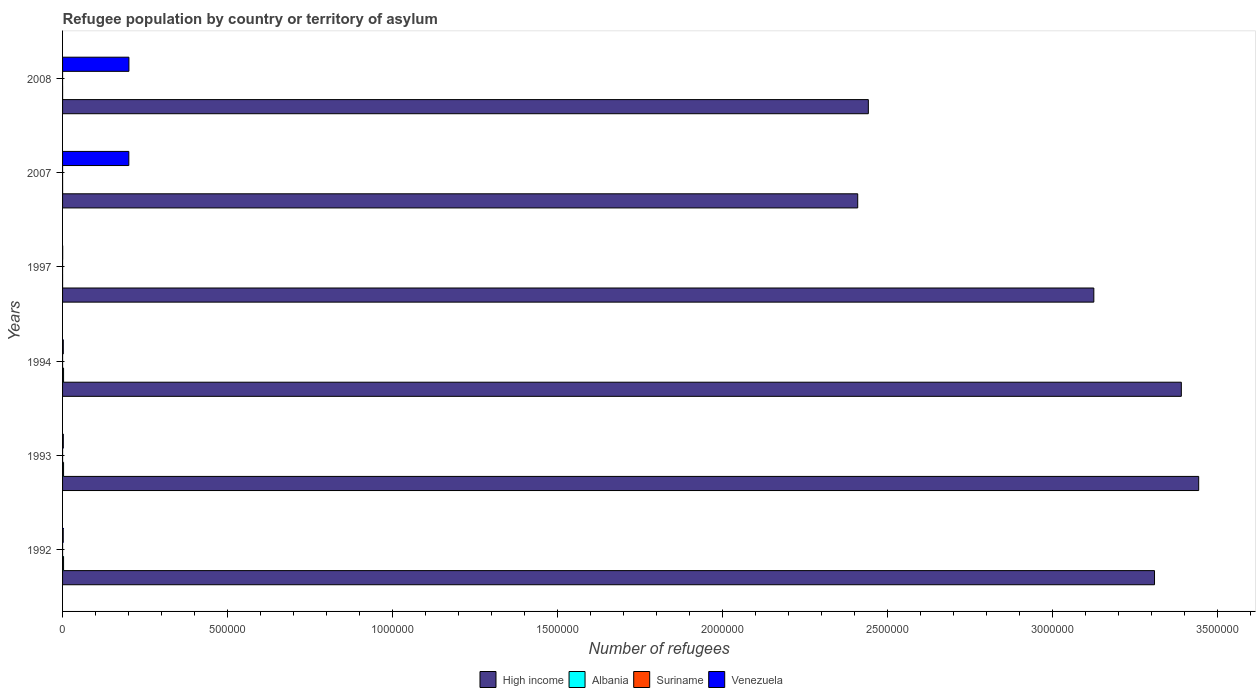How many different coloured bars are there?
Provide a succinct answer. 4. How many bars are there on the 2nd tick from the top?
Provide a succinct answer. 4. How many bars are there on the 6th tick from the bottom?
Offer a terse response. 4. What is the number of refugees in Albania in 2007?
Your answer should be very brief. 77. Across all years, what is the maximum number of refugees in High income?
Ensure brevity in your answer.  3.44e+06. Across all years, what is the minimum number of refugees in Venezuela?
Offer a terse response. 301. What is the total number of refugees in Suriname in the graph?
Offer a very short reply. 154. What is the difference between the number of refugees in Albania in 1994 and that in 1997?
Keep it short and to the point. 2970. What is the difference between the number of refugees in Albania in 1992 and the number of refugees in Suriname in 2007?
Keep it short and to the point. 2999. What is the average number of refugees in Suriname per year?
Make the answer very short. 25.67. In the year 1994, what is the difference between the number of refugees in Suriname and number of refugees in Venezuela?
Make the answer very short. -2138. What is the ratio of the number of refugees in Albania in 1994 to that in 2008?
Make the answer very short. 46.15. Is the number of refugees in High income in 1992 less than that in 2007?
Your answer should be compact. No. Is the difference between the number of refugees in Suriname in 1993 and 2008 greater than the difference between the number of refugees in Venezuela in 1993 and 2008?
Keep it short and to the point. Yes. What is the difference between the highest and the second highest number of refugees in Venezuela?
Give a very brief answer. 254. What is the difference between the highest and the lowest number of refugees in Venezuela?
Your response must be concise. 2.01e+05. In how many years, is the number of refugees in Albania greater than the average number of refugees in Albania taken over all years?
Keep it short and to the point. 3. What does the 1st bar from the top in 1993 represents?
Offer a terse response. Venezuela. Is it the case that in every year, the sum of the number of refugees in Suriname and number of refugees in Albania is greater than the number of refugees in Venezuela?
Give a very brief answer. No. How many bars are there?
Keep it short and to the point. 24. Are all the bars in the graph horizontal?
Ensure brevity in your answer.  Yes. What is the difference between two consecutive major ticks on the X-axis?
Provide a succinct answer. 5.00e+05. Does the graph contain grids?
Keep it short and to the point. No. How many legend labels are there?
Make the answer very short. 4. What is the title of the graph?
Your answer should be compact. Refugee population by country or territory of asylum. Does "Comoros" appear as one of the legend labels in the graph?
Provide a succinct answer. No. What is the label or title of the X-axis?
Keep it short and to the point. Number of refugees. What is the Number of refugees of High income in 1992?
Provide a short and direct response. 3.31e+06. What is the Number of refugees of Albania in 1992?
Offer a very short reply. 3000. What is the Number of refugees in Venezuela in 1992?
Keep it short and to the point. 1990. What is the Number of refugees of High income in 1993?
Your answer should be very brief. 3.44e+06. What is the Number of refugees of Albania in 1993?
Provide a short and direct response. 3000. What is the Number of refugees in Venezuela in 1993?
Your response must be concise. 2221. What is the Number of refugees of High income in 1994?
Ensure brevity in your answer.  3.39e+06. What is the Number of refugees of Albania in 1994?
Keep it short and to the point. 3000. What is the Number of refugees in Suriname in 1994?
Ensure brevity in your answer.  39. What is the Number of refugees in Venezuela in 1994?
Provide a short and direct response. 2177. What is the Number of refugees of High income in 1997?
Offer a terse response. 3.13e+06. What is the Number of refugees in Venezuela in 1997?
Ensure brevity in your answer.  301. What is the Number of refugees of High income in 2007?
Keep it short and to the point. 2.41e+06. What is the Number of refugees in Albania in 2007?
Give a very brief answer. 77. What is the Number of refugees in Suriname in 2007?
Provide a succinct answer. 1. What is the Number of refugees in Venezuela in 2007?
Make the answer very short. 2.01e+05. What is the Number of refugees of High income in 2008?
Your answer should be compact. 2.44e+06. What is the Number of refugees of Albania in 2008?
Offer a terse response. 65. What is the Number of refugees of Venezuela in 2008?
Keep it short and to the point. 2.01e+05. Across all years, what is the maximum Number of refugees in High income?
Make the answer very short. 3.44e+06. Across all years, what is the maximum Number of refugees of Albania?
Your answer should be compact. 3000. Across all years, what is the maximum Number of refugees of Venezuela?
Your answer should be compact. 2.01e+05. Across all years, what is the minimum Number of refugees of High income?
Give a very brief answer. 2.41e+06. Across all years, what is the minimum Number of refugees in Venezuela?
Your answer should be very brief. 301. What is the total Number of refugees in High income in the graph?
Provide a short and direct response. 1.81e+07. What is the total Number of refugees in Albania in the graph?
Provide a succinct answer. 9172. What is the total Number of refugees of Suriname in the graph?
Your response must be concise. 154. What is the total Number of refugees of Venezuela in the graph?
Offer a very short reply. 4.09e+05. What is the difference between the Number of refugees of High income in 1992 and that in 1993?
Your answer should be compact. -1.34e+05. What is the difference between the Number of refugees in Venezuela in 1992 and that in 1993?
Make the answer very short. -231. What is the difference between the Number of refugees in High income in 1992 and that in 1994?
Offer a very short reply. -8.13e+04. What is the difference between the Number of refugees of Suriname in 1992 and that in 1994?
Your answer should be compact. 13. What is the difference between the Number of refugees in Venezuela in 1992 and that in 1994?
Offer a very short reply. -187. What is the difference between the Number of refugees of High income in 1992 and that in 1997?
Make the answer very short. 1.84e+05. What is the difference between the Number of refugees in Albania in 1992 and that in 1997?
Your answer should be compact. 2970. What is the difference between the Number of refugees in Venezuela in 1992 and that in 1997?
Ensure brevity in your answer.  1689. What is the difference between the Number of refugees in High income in 1992 and that in 2007?
Your answer should be very brief. 9.00e+05. What is the difference between the Number of refugees of Albania in 1992 and that in 2007?
Offer a terse response. 2923. What is the difference between the Number of refugees of Suriname in 1992 and that in 2007?
Make the answer very short. 51. What is the difference between the Number of refugees in Venezuela in 1992 and that in 2007?
Your response must be concise. -1.99e+05. What is the difference between the Number of refugees of High income in 1992 and that in 2008?
Provide a short and direct response. 8.68e+05. What is the difference between the Number of refugees in Albania in 1992 and that in 2008?
Your answer should be very brief. 2935. What is the difference between the Number of refugees of Suriname in 1992 and that in 2008?
Provide a succinct answer. 51. What is the difference between the Number of refugees of Venezuela in 1992 and that in 2008?
Your answer should be very brief. -1.99e+05. What is the difference between the Number of refugees of High income in 1993 and that in 1994?
Offer a terse response. 5.26e+04. What is the difference between the Number of refugees in Albania in 1993 and that in 1994?
Offer a terse response. 0. What is the difference between the Number of refugees in Suriname in 1993 and that in 1994?
Offer a very short reply. 11. What is the difference between the Number of refugees in Venezuela in 1993 and that in 1994?
Your answer should be compact. 44. What is the difference between the Number of refugees of High income in 1993 and that in 1997?
Give a very brief answer. 3.18e+05. What is the difference between the Number of refugees of Albania in 1993 and that in 1997?
Make the answer very short. 2970. What is the difference between the Number of refugees in Venezuela in 1993 and that in 1997?
Ensure brevity in your answer.  1920. What is the difference between the Number of refugees in High income in 1993 and that in 2007?
Keep it short and to the point. 1.03e+06. What is the difference between the Number of refugees of Albania in 1993 and that in 2007?
Make the answer very short. 2923. What is the difference between the Number of refugees of Suriname in 1993 and that in 2007?
Offer a very short reply. 49. What is the difference between the Number of refugees of Venezuela in 1993 and that in 2007?
Make the answer very short. -1.99e+05. What is the difference between the Number of refugees of High income in 1993 and that in 2008?
Provide a succinct answer. 1.00e+06. What is the difference between the Number of refugees in Albania in 1993 and that in 2008?
Your answer should be compact. 2935. What is the difference between the Number of refugees of Suriname in 1993 and that in 2008?
Your answer should be compact. 49. What is the difference between the Number of refugees of Venezuela in 1993 and that in 2008?
Your answer should be very brief. -1.99e+05. What is the difference between the Number of refugees in High income in 1994 and that in 1997?
Provide a short and direct response. 2.65e+05. What is the difference between the Number of refugees of Albania in 1994 and that in 1997?
Your answer should be very brief. 2970. What is the difference between the Number of refugees of Suriname in 1994 and that in 1997?
Provide a succinct answer. 28. What is the difference between the Number of refugees of Venezuela in 1994 and that in 1997?
Keep it short and to the point. 1876. What is the difference between the Number of refugees of High income in 1994 and that in 2007?
Keep it short and to the point. 9.81e+05. What is the difference between the Number of refugees of Albania in 1994 and that in 2007?
Your response must be concise. 2923. What is the difference between the Number of refugees in Suriname in 1994 and that in 2007?
Your answer should be very brief. 38. What is the difference between the Number of refugees in Venezuela in 1994 and that in 2007?
Give a very brief answer. -1.99e+05. What is the difference between the Number of refugees in High income in 1994 and that in 2008?
Ensure brevity in your answer.  9.49e+05. What is the difference between the Number of refugees of Albania in 1994 and that in 2008?
Keep it short and to the point. 2935. What is the difference between the Number of refugees in Venezuela in 1994 and that in 2008?
Provide a succinct answer. -1.99e+05. What is the difference between the Number of refugees in High income in 1997 and that in 2007?
Give a very brief answer. 7.16e+05. What is the difference between the Number of refugees in Albania in 1997 and that in 2007?
Provide a short and direct response. -47. What is the difference between the Number of refugees of Suriname in 1997 and that in 2007?
Make the answer very short. 10. What is the difference between the Number of refugees in Venezuela in 1997 and that in 2007?
Offer a terse response. -2.01e+05. What is the difference between the Number of refugees in High income in 1997 and that in 2008?
Make the answer very short. 6.84e+05. What is the difference between the Number of refugees in Albania in 1997 and that in 2008?
Give a very brief answer. -35. What is the difference between the Number of refugees of Venezuela in 1997 and that in 2008?
Your answer should be very brief. -2.01e+05. What is the difference between the Number of refugees of High income in 2007 and that in 2008?
Ensure brevity in your answer.  -3.22e+04. What is the difference between the Number of refugees of Albania in 2007 and that in 2008?
Ensure brevity in your answer.  12. What is the difference between the Number of refugees of Venezuela in 2007 and that in 2008?
Provide a short and direct response. -254. What is the difference between the Number of refugees in High income in 1992 and the Number of refugees in Albania in 1993?
Keep it short and to the point. 3.31e+06. What is the difference between the Number of refugees in High income in 1992 and the Number of refugees in Suriname in 1993?
Provide a succinct answer. 3.31e+06. What is the difference between the Number of refugees in High income in 1992 and the Number of refugees in Venezuela in 1993?
Provide a succinct answer. 3.31e+06. What is the difference between the Number of refugees in Albania in 1992 and the Number of refugees in Suriname in 1993?
Offer a very short reply. 2950. What is the difference between the Number of refugees in Albania in 1992 and the Number of refugees in Venezuela in 1993?
Make the answer very short. 779. What is the difference between the Number of refugees of Suriname in 1992 and the Number of refugees of Venezuela in 1993?
Make the answer very short. -2169. What is the difference between the Number of refugees of High income in 1992 and the Number of refugees of Albania in 1994?
Make the answer very short. 3.31e+06. What is the difference between the Number of refugees in High income in 1992 and the Number of refugees in Suriname in 1994?
Offer a terse response. 3.31e+06. What is the difference between the Number of refugees of High income in 1992 and the Number of refugees of Venezuela in 1994?
Your response must be concise. 3.31e+06. What is the difference between the Number of refugees in Albania in 1992 and the Number of refugees in Suriname in 1994?
Make the answer very short. 2961. What is the difference between the Number of refugees in Albania in 1992 and the Number of refugees in Venezuela in 1994?
Make the answer very short. 823. What is the difference between the Number of refugees in Suriname in 1992 and the Number of refugees in Venezuela in 1994?
Your response must be concise. -2125. What is the difference between the Number of refugees of High income in 1992 and the Number of refugees of Albania in 1997?
Offer a terse response. 3.31e+06. What is the difference between the Number of refugees in High income in 1992 and the Number of refugees in Suriname in 1997?
Give a very brief answer. 3.31e+06. What is the difference between the Number of refugees of High income in 1992 and the Number of refugees of Venezuela in 1997?
Provide a short and direct response. 3.31e+06. What is the difference between the Number of refugees in Albania in 1992 and the Number of refugees in Suriname in 1997?
Make the answer very short. 2989. What is the difference between the Number of refugees of Albania in 1992 and the Number of refugees of Venezuela in 1997?
Give a very brief answer. 2699. What is the difference between the Number of refugees in Suriname in 1992 and the Number of refugees in Venezuela in 1997?
Provide a succinct answer. -249. What is the difference between the Number of refugees of High income in 1992 and the Number of refugees of Albania in 2007?
Provide a short and direct response. 3.31e+06. What is the difference between the Number of refugees in High income in 1992 and the Number of refugees in Suriname in 2007?
Provide a short and direct response. 3.31e+06. What is the difference between the Number of refugees in High income in 1992 and the Number of refugees in Venezuela in 2007?
Give a very brief answer. 3.11e+06. What is the difference between the Number of refugees of Albania in 1992 and the Number of refugees of Suriname in 2007?
Your response must be concise. 2999. What is the difference between the Number of refugees in Albania in 1992 and the Number of refugees in Venezuela in 2007?
Give a very brief answer. -1.98e+05. What is the difference between the Number of refugees in Suriname in 1992 and the Number of refugees in Venezuela in 2007?
Ensure brevity in your answer.  -2.01e+05. What is the difference between the Number of refugees of High income in 1992 and the Number of refugees of Albania in 2008?
Make the answer very short. 3.31e+06. What is the difference between the Number of refugees in High income in 1992 and the Number of refugees in Suriname in 2008?
Give a very brief answer. 3.31e+06. What is the difference between the Number of refugees of High income in 1992 and the Number of refugees of Venezuela in 2008?
Ensure brevity in your answer.  3.11e+06. What is the difference between the Number of refugees of Albania in 1992 and the Number of refugees of Suriname in 2008?
Offer a terse response. 2999. What is the difference between the Number of refugees in Albania in 1992 and the Number of refugees in Venezuela in 2008?
Your answer should be compact. -1.98e+05. What is the difference between the Number of refugees of Suriname in 1992 and the Number of refugees of Venezuela in 2008?
Offer a very short reply. -2.01e+05. What is the difference between the Number of refugees in High income in 1993 and the Number of refugees in Albania in 1994?
Ensure brevity in your answer.  3.44e+06. What is the difference between the Number of refugees in High income in 1993 and the Number of refugees in Suriname in 1994?
Your response must be concise. 3.44e+06. What is the difference between the Number of refugees of High income in 1993 and the Number of refugees of Venezuela in 1994?
Offer a terse response. 3.44e+06. What is the difference between the Number of refugees of Albania in 1993 and the Number of refugees of Suriname in 1994?
Provide a short and direct response. 2961. What is the difference between the Number of refugees of Albania in 1993 and the Number of refugees of Venezuela in 1994?
Your answer should be very brief. 823. What is the difference between the Number of refugees in Suriname in 1993 and the Number of refugees in Venezuela in 1994?
Your response must be concise. -2127. What is the difference between the Number of refugees in High income in 1993 and the Number of refugees in Albania in 1997?
Your answer should be compact. 3.44e+06. What is the difference between the Number of refugees of High income in 1993 and the Number of refugees of Suriname in 1997?
Ensure brevity in your answer.  3.44e+06. What is the difference between the Number of refugees in High income in 1993 and the Number of refugees in Venezuela in 1997?
Ensure brevity in your answer.  3.44e+06. What is the difference between the Number of refugees of Albania in 1993 and the Number of refugees of Suriname in 1997?
Offer a very short reply. 2989. What is the difference between the Number of refugees of Albania in 1993 and the Number of refugees of Venezuela in 1997?
Offer a very short reply. 2699. What is the difference between the Number of refugees of Suriname in 1993 and the Number of refugees of Venezuela in 1997?
Provide a succinct answer. -251. What is the difference between the Number of refugees in High income in 1993 and the Number of refugees in Albania in 2007?
Keep it short and to the point. 3.44e+06. What is the difference between the Number of refugees in High income in 1993 and the Number of refugees in Suriname in 2007?
Keep it short and to the point. 3.44e+06. What is the difference between the Number of refugees in High income in 1993 and the Number of refugees in Venezuela in 2007?
Keep it short and to the point. 3.24e+06. What is the difference between the Number of refugees of Albania in 1993 and the Number of refugees of Suriname in 2007?
Provide a succinct answer. 2999. What is the difference between the Number of refugees of Albania in 1993 and the Number of refugees of Venezuela in 2007?
Your answer should be very brief. -1.98e+05. What is the difference between the Number of refugees of Suriname in 1993 and the Number of refugees of Venezuela in 2007?
Ensure brevity in your answer.  -2.01e+05. What is the difference between the Number of refugees in High income in 1993 and the Number of refugees in Albania in 2008?
Offer a terse response. 3.44e+06. What is the difference between the Number of refugees in High income in 1993 and the Number of refugees in Suriname in 2008?
Your response must be concise. 3.44e+06. What is the difference between the Number of refugees in High income in 1993 and the Number of refugees in Venezuela in 2008?
Your answer should be compact. 3.24e+06. What is the difference between the Number of refugees in Albania in 1993 and the Number of refugees in Suriname in 2008?
Offer a very short reply. 2999. What is the difference between the Number of refugees of Albania in 1993 and the Number of refugees of Venezuela in 2008?
Your answer should be very brief. -1.98e+05. What is the difference between the Number of refugees in Suriname in 1993 and the Number of refugees in Venezuela in 2008?
Provide a succinct answer. -2.01e+05. What is the difference between the Number of refugees in High income in 1994 and the Number of refugees in Albania in 1997?
Your answer should be very brief. 3.39e+06. What is the difference between the Number of refugees in High income in 1994 and the Number of refugees in Suriname in 1997?
Offer a very short reply. 3.39e+06. What is the difference between the Number of refugees in High income in 1994 and the Number of refugees in Venezuela in 1997?
Your answer should be very brief. 3.39e+06. What is the difference between the Number of refugees of Albania in 1994 and the Number of refugees of Suriname in 1997?
Offer a very short reply. 2989. What is the difference between the Number of refugees in Albania in 1994 and the Number of refugees in Venezuela in 1997?
Offer a terse response. 2699. What is the difference between the Number of refugees in Suriname in 1994 and the Number of refugees in Venezuela in 1997?
Your answer should be compact. -262. What is the difference between the Number of refugees of High income in 1994 and the Number of refugees of Albania in 2007?
Give a very brief answer. 3.39e+06. What is the difference between the Number of refugees of High income in 1994 and the Number of refugees of Suriname in 2007?
Your answer should be very brief. 3.39e+06. What is the difference between the Number of refugees of High income in 1994 and the Number of refugees of Venezuela in 2007?
Your answer should be compact. 3.19e+06. What is the difference between the Number of refugees in Albania in 1994 and the Number of refugees in Suriname in 2007?
Keep it short and to the point. 2999. What is the difference between the Number of refugees in Albania in 1994 and the Number of refugees in Venezuela in 2007?
Provide a short and direct response. -1.98e+05. What is the difference between the Number of refugees of Suriname in 1994 and the Number of refugees of Venezuela in 2007?
Offer a terse response. -2.01e+05. What is the difference between the Number of refugees of High income in 1994 and the Number of refugees of Albania in 2008?
Offer a very short reply. 3.39e+06. What is the difference between the Number of refugees in High income in 1994 and the Number of refugees in Suriname in 2008?
Make the answer very short. 3.39e+06. What is the difference between the Number of refugees in High income in 1994 and the Number of refugees in Venezuela in 2008?
Provide a short and direct response. 3.19e+06. What is the difference between the Number of refugees of Albania in 1994 and the Number of refugees of Suriname in 2008?
Your answer should be compact. 2999. What is the difference between the Number of refugees in Albania in 1994 and the Number of refugees in Venezuela in 2008?
Offer a very short reply. -1.98e+05. What is the difference between the Number of refugees of Suriname in 1994 and the Number of refugees of Venezuela in 2008?
Provide a short and direct response. -2.01e+05. What is the difference between the Number of refugees in High income in 1997 and the Number of refugees in Albania in 2007?
Provide a succinct answer. 3.13e+06. What is the difference between the Number of refugees in High income in 1997 and the Number of refugees in Suriname in 2007?
Ensure brevity in your answer.  3.13e+06. What is the difference between the Number of refugees of High income in 1997 and the Number of refugees of Venezuela in 2007?
Offer a very short reply. 2.93e+06. What is the difference between the Number of refugees in Albania in 1997 and the Number of refugees in Suriname in 2007?
Your answer should be very brief. 29. What is the difference between the Number of refugees in Albania in 1997 and the Number of refugees in Venezuela in 2007?
Make the answer very short. -2.01e+05. What is the difference between the Number of refugees of Suriname in 1997 and the Number of refugees of Venezuela in 2007?
Ensure brevity in your answer.  -2.01e+05. What is the difference between the Number of refugees in High income in 1997 and the Number of refugees in Albania in 2008?
Make the answer very short. 3.13e+06. What is the difference between the Number of refugees of High income in 1997 and the Number of refugees of Suriname in 2008?
Offer a terse response. 3.13e+06. What is the difference between the Number of refugees in High income in 1997 and the Number of refugees in Venezuela in 2008?
Offer a very short reply. 2.93e+06. What is the difference between the Number of refugees of Albania in 1997 and the Number of refugees of Suriname in 2008?
Provide a succinct answer. 29. What is the difference between the Number of refugees in Albania in 1997 and the Number of refugees in Venezuela in 2008?
Your answer should be compact. -2.01e+05. What is the difference between the Number of refugees in Suriname in 1997 and the Number of refugees in Venezuela in 2008?
Give a very brief answer. -2.01e+05. What is the difference between the Number of refugees in High income in 2007 and the Number of refugees in Albania in 2008?
Make the answer very short. 2.41e+06. What is the difference between the Number of refugees of High income in 2007 and the Number of refugees of Suriname in 2008?
Make the answer very short. 2.41e+06. What is the difference between the Number of refugees in High income in 2007 and the Number of refugees in Venezuela in 2008?
Your answer should be very brief. 2.21e+06. What is the difference between the Number of refugees in Albania in 2007 and the Number of refugees in Venezuela in 2008?
Make the answer very short. -2.01e+05. What is the difference between the Number of refugees in Suriname in 2007 and the Number of refugees in Venezuela in 2008?
Offer a very short reply. -2.01e+05. What is the average Number of refugees of High income per year?
Ensure brevity in your answer.  3.02e+06. What is the average Number of refugees of Albania per year?
Provide a short and direct response. 1528.67. What is the average Number of refugees in Suriname per year?
Your answer should be compact. 25.67. What is the average Number of refugees in Venezuela per year?
Keep it short and to the point. 6.81e+04. In the year 1992, what is the difference between the Number of refugees of High income and Number of refugees of Albania?
Keep it short and to the point. 3.31e+06. In the year 1992, what is the difference between the Number of refugees of High income and Number of refugees of Suriname?
Your answer should be very brief. 3.31e+06. In the year 1992, what is the difference between the Number of refugees of High income and Number of refugees of Venezuela?
Your response must be concise. 3.31e+06. In the year 1992, what is the difference between the Number of refugees of Albania and Number of refugees of Suriname?
Your answer should be very brief. 2948. In the year 1992, what is the difference between the Number of refugees of Albania and Number of refugees of Venezuela?
Your answer should be compact. 1010. In the year 1992, what is the difference between the Number of refugees of Suriname and Number of refugees of Venezuela?
Keep it short and to the point. -1938. In the year 1993, what is the difference between the Number of refugees of High income and Number of refugees of Albania?
Your response must be concise. 3.44e+06. In the year 1993, what is the difference between the Number of refugees in High income and Number of refugees in Suriname?
Provide a succinct answer. 3.44e+06. In the year 1993, what is the difference between the Number of refugees in High income and Number of refugees in Venezuela?
Give a very brief answer. 3.44e+06. In the year 1993, what is the difference between the Number of refugees of Albania and Number of refugees of Suriname?
Your answer should be very brief. 2950. In the year 1993, what is the difference between the Number of refugees in Albania and Number of refugees in Venezuela?
Keep it short and to the point. 779. In the year 1993, what is the difference between the Number of refugees of Suriname and Number of refugees of Venezuela?
Your response must be concise. -2171. In the year 1994, what is the difference between the Number of refugees in High income and Number of refugees in Albania?
Provide a succinct answer. 3.39e+06. In the year 1994, what is the difference between the Number of refugees of High income and Number of refugees of Suriname?
Your response must be concise. 3.39e+06. In the year 1994, what is the difference between the Number of refugees of High income and Number of refugees of Venezuela?
Make the answer very short. 3.39e+06. In the year 1994, what is the difference between the Number of refugees of Albania and Number of refugees of Suriname?
Provide a succinct answer. 2961. In the year 1994, what is the difference between the Number of refugees of Albania and Number of refugees of Venezuela?
Ensure brevity in your answer.  823. In the year 1994, what is the difference between the Number of refugees in Suriname and Number of refugees in Venezuela?
Offer a terse response. -2138. In the year 1997, what is the difference between the Number of refugees in High income and Number of refugees in Albania?
Ensure brevity in your answer.  3.13e+06. In the year 1997, what is the difference between the Number of refugees in High income and Number of refugees in Suriname?
Ensure brevity in your answer.  3.13e+06. In the year 1997, what is the difference between the Number of refugees in High income and Number of refugees in Venezuela?
Your answer should be compact. 3.13e+06. In the year 1997, what is the difference between the Number of refugees of Albania and Number of refugees of Suriname?
Keep it short and to the point. 19. In the year 1997, what is the difference between the Number of refugees in Albania and Number of refugees in Venezuela?
Make the answer very short. -271. In the year 1997, what is the difference between the Number of refugees in Suriname and Number of refugees in Venezuela?
Offer a very short reply. -290. In the year 2007, what is the difference between the Number of refugees in High income and Number of refugees in Albania?
Ensure brevity in your answer.  2.41e+06. In the year 2007, what is the difference between the Number of refugees of High income and Number of refugees of Suriname?
Ensure brevity in your answer.  2.41e+06. In the year 2007, what is the difference between the Number of refugees of High income and Number of refugees of Venezuela?
Ensure brevity in your answer.  2.21e+06. In the year 2007, what is the difference between the Number of refugees of Albania and Number of refugees of Venezuela?
Your response must be concise. -2.01e+05. In the year 2007, what is the difference between the Number of refugees in Suriname and Number of refugees in Venezuela?
Your response must be concise. -2.01e+05. In the year 2008, what is the difference between the Number of refugees of High income and Number of refugees of Albania?
Offer a terse response. 2.44e+06. In the year 2008, what is the difference between the Number of refugees of High income and Number of refugees of Suriname?
Provide a succinct answer. 2.44e+06. In the year 2008, what is the difference between the Number of refugees in High income and Number of refugees in Venezuela?
Provide a short and direct response. 2.24e+06. In the year 2008, what is the difference between the Number of refugees in Albania and Number of refugees in Suriname?
Give a very brief answer. 64. In the year 2008, what is the difference between the Number of refugees in Albania and Number of refugees in Venezuela?
Provide a short and direct response. -2.01e+05. In the year 2008, what is the difference between the Number of refugees in Suriname and Number of refugees in Venezuela?
Keep it short and to the point. -2.01e+05. What is the ratio of the Number of refugees of High income in 1992 to that in 1993?
Ensure brevity in your answer.  0.96. What is the ratio of the Number of refugees of Suriname in 1992 to that in 1993?
Offer a terse response. 1.04. What is the ratio of the Number of refugees in Venezuela in 1992 to that in 1993?
Offer a terse response. 0.9. What is the ratio of the Number of refugees of High income in 1992 to that in 1994?
Provide a short and direct response. 0.98. What is the ratio of the Number of refugees of Albania in 1992 to that in 1994?
Provide a short and direct response. 1. What is the ratio of the Number of refugees of Venezuela in 1992 to that in 1994?
Ensure brevity in your answer.  0.91. What is the ratio of the Number of refugees of High income in 1992 to that in 1997?
Offer a very short reply. 1.06. What is the ratio of the Number of refugees in Albania in 1992 to that in 1997?
Your answer should be very brief. 100. What is the ratio of the Number of refugees of Suriname in 1992 to that in 1997?
Your response must be concise. 4.73. What is the ratio of the Number of refugees of Venezuela in 1992 to that in 1997?
Provide a succinct answer. 6.61. What is the ratio of the Number of refugees in High income in 1992 to that in 2007?
Provide a short and direct response. 1.37. What is the ratio of the Number of refugees of Albania in 1992 to that in 2007?
Your answer should be very brief. 38.96. What is the ratio of the Number of refugees in Venezuela in 1992 to that in 2007?
Give a very brief answer. 0.01. What is the ratio of the Number of refugees of High income in 1992 to that in 2008?
Your response must be concise. 1.36. What is the ratio of the Number of refugees of Albania in 1992 to that in 2008?
Offer a very short reply. 46.15. What is the ratio of the Number of refugees in Suriname in 1992 to that in 2008?
Your answer should be very brief. 52. What is the ratio of the Number of refugees in Venezuela in 1992 to that in 2008?
Give a very brief answer. 0.01. What is the ratio of the Number of refugees in High income in 1993 to that in 1994?
Your answer should be very brief. 1.02. What is the ratio of the Number of refugees of Suriname in 1993 to that in 1994?
Offer a terse response. 1.28. What is the ratio of the Number of refugees in Venezuela in 1993 to that in 1994?
Your response must be concise. 1.02. What is the ratio of the Number of refugees of High income in 1993 to that in 1997?
Your answer should be very brief. 1.1. What is the ratio of the Number of refugees in Suriname in 1993 to that in 1997?
Your response must be concise. 4.55. What is the ratio of the Number of refugees of Venezuela in 1993 to that in 1997?
Provide a short and direct response. 7.38. What is the ratio of the Number of refugees in High income in 1993 to that in 2007?
Your answer should be very brief. 1.43. What is the ratio of the Number of refugees in Albania in 1993 to that in 2007?
Your answer should be very brief. 38.96. What is the ratio of the Number of refugees in Venezuela in 1993 to that in 2007?
Your answer should be very brief. 0.01. What is the ratio of the Number of refugees in High income in 1993 to that in 2008?
Provide a short and direct response. 1.41. What is the ratio of the Number of refugees of Albania in 1993 to that in 2008?
Provide a short and direct response. 46.15. What is the ratio of the Number of refugees in Suriname in 1993 to that in 2008?
Keep it short and to the point. 50. What is the ratio of the Number of refugees of Venezuela in 1993 to that in 2008?
Your answer should be compact. 0.01. What is the ratio of the Number of refugees of High income in 1994 to that in 1997?
Provide a succinct answer. 1.08. What is the ratio of the Number of refugees of Suriname in 1994 to that in 1997?
Provide a short and direct response. 3.55. What is the ratio of the Number of refugees of Venezuela in 1994 to that in 1997?
Ensure brevity in your answer.  7.23. What is the ratio of the Number of refugees of High income in 1994 to that in 2007?
Give a very brief answer. 1.41. What is the ratio of the Number of refugees of Albania in 1994 to that in 2007?
Give a very brief answer. 38.96. What is the ratio of the Number of refugees in Venezuela in 1994 to that in 2007?
Give a very brief answer. 0.01. What is the ratio of the Number of refugees in High income in 1994 to that in 2008?
Offer a terse response. 1.39. What is the ratio of the Number of refugees of Albania in 1994 to that in 2008?
Offer a terse response. 46.15. What is the ratio of the Number of refugees in Suriname in 1994 to that in 2008?
Make the answer very short. 39. What is the ratio of the Number of refugees in Venezuela in 1994 to that in 2008?
Ensure brevity in your answer.  0.01. What is the ratio of the Number of refugees in High income in 1997 to that in 2007?
Make the answer very short. 1.3. What is the ratio of the Number of refugees of Albania in 1997 to that in 2007?
Your answer should be very brief. 0.39. What is the ratio of the Number of refugees of Venezuela in 1997 to that in 2007?
Your answer should be very brief. 0. What is the ratio of the Number of refugees in High income in 1997 to that in 2008?
Offer a terse response. 1.28. What is the ratio of the Number of refugees of Albania in 1997 to that in 2008?
Make the answer very short. 0.46. What is the ratio of the Number of refugees of Suriname in 1997 to that in 2008?
Offer a very short reply. 11. What is the ratio of the Number of refugees of Venezuela in 1997 to that in 2008?
Ensure brevity in your answer.  0. What is the ratio of the Number of refugees of High income in 2007 to that in 2008?
Offer a terse response. 0.99. What is the ratio of the Number of refugees in Albania in 2007 to that in 2008?
Provide a short and direct response. 1.18. What is the ratio of the Number of refugees of Suriname in 2007 to that in 2008?
Provide a succinct answer. 1. What is the difference between the highest and the second highest Number of refugees in High income?
Ensure brevity in your answer.  5.26e+04. What is the difference between the highest and the second highest Number of refugees in Albania?
Your response must be concise. 0. What is the difference between the highest and the second highest Number of refugees of Venezuela?
Your answer should be very brief. 254. What is the difference between the highest and the lowest Number of refugees in High income?
Your response must be concise. 1.03e+06. What is the difference between the highest and the lowest Number of refugees of Albania?
Ensure brevity in your answer.  2970. What is the difference between the highest and the lowest Number of refugees of Venezuela?
Offer a very short reply. 2.01e+05. 